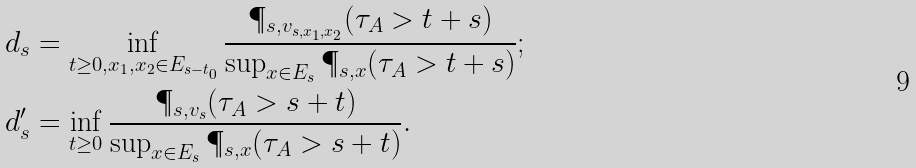<formula> <loc_0><loc_0><loc_500><loc_500>& d _ { s } = \inf _ { t \geq 0 , x _ { 1 } , x _ { 2 } \in E _ { s - t _ { 0 } } } \frac { \P _ { s , v _ { s , x _ { 1 } , x _ { 2 } } } ( \tau _ { A } > t + s ) } { \sup _ { x \in E _ { s } } \P _ { s , x } ( \tau _ { A } > t + s ) } ; \\ & d ^ { \prime } _ { s } = \inf _ { t \geq 0 } \frac { \P _ { s , v _ { s } } ( \tau _ { A } > s + t ) } { \sup _ { x \in E _ { s } } \P _ { s , x } ( \tau _ { A } > s + t ) } .</formula> 